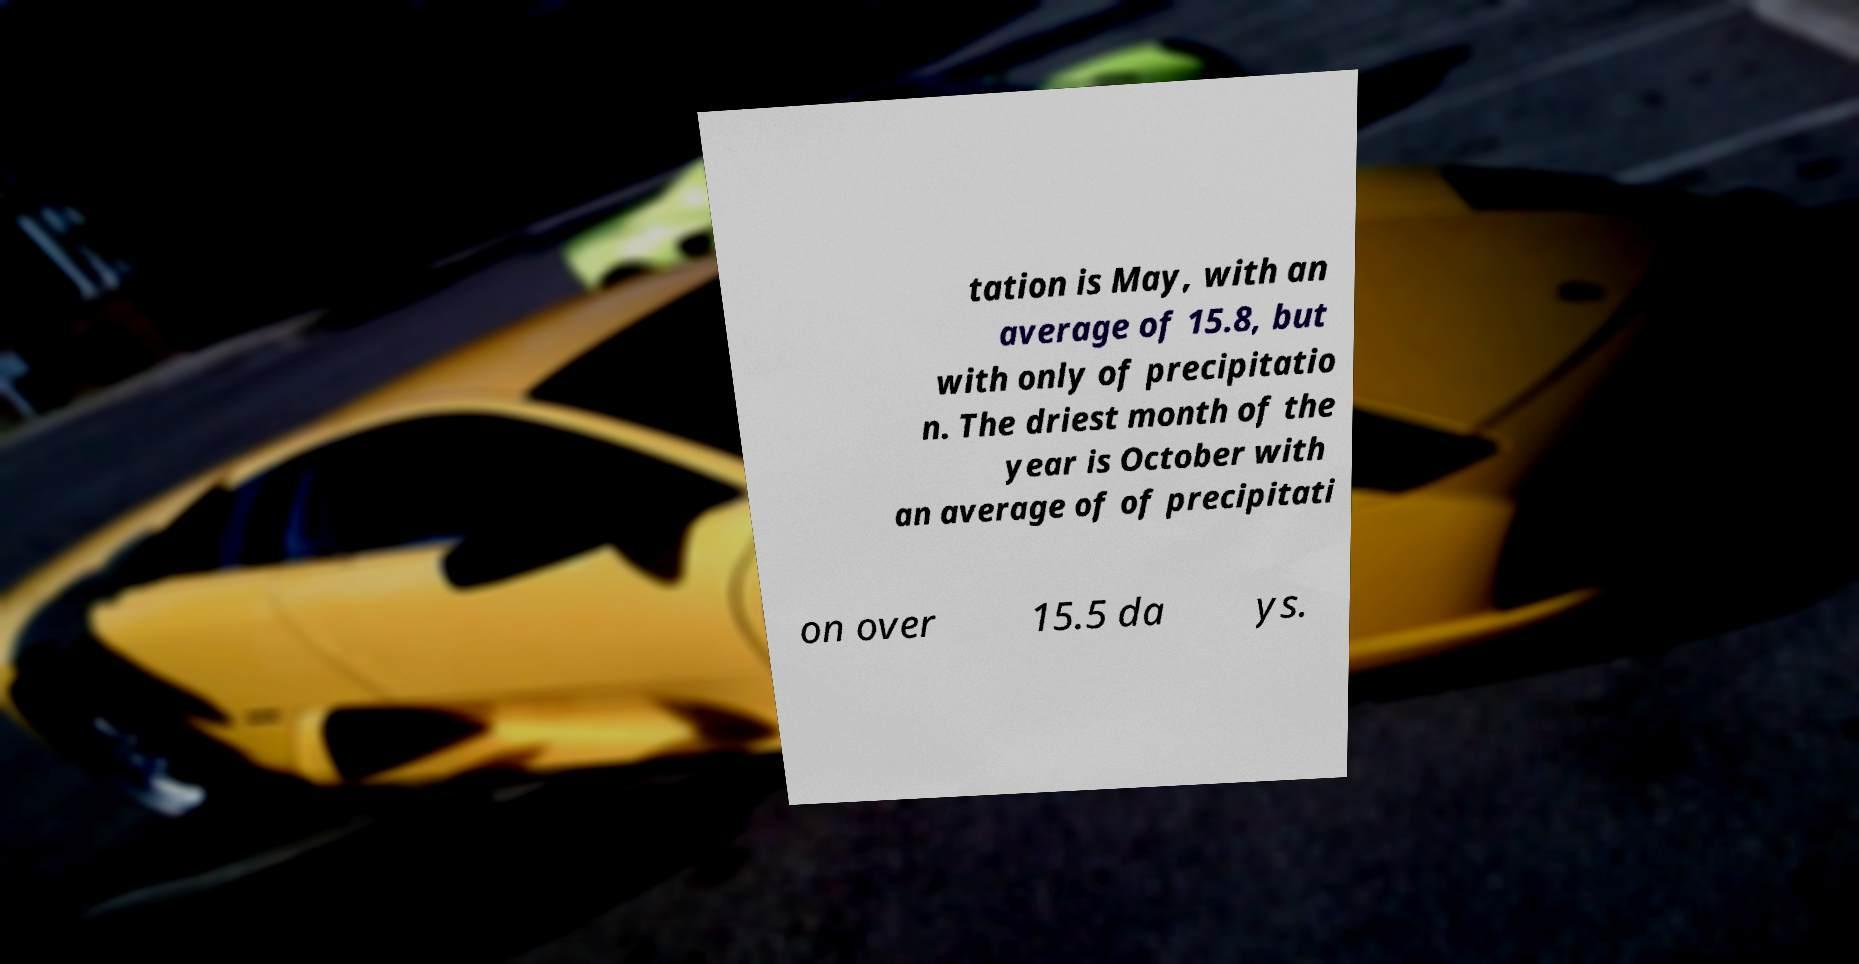What messages or text are displayed in this image? I need them in a readable, typed format. tation is May, with an average of 15.8, but with only of precipitatio n. The driest month of the year is October with an average of of precipitati on over 15.5 da ys. 